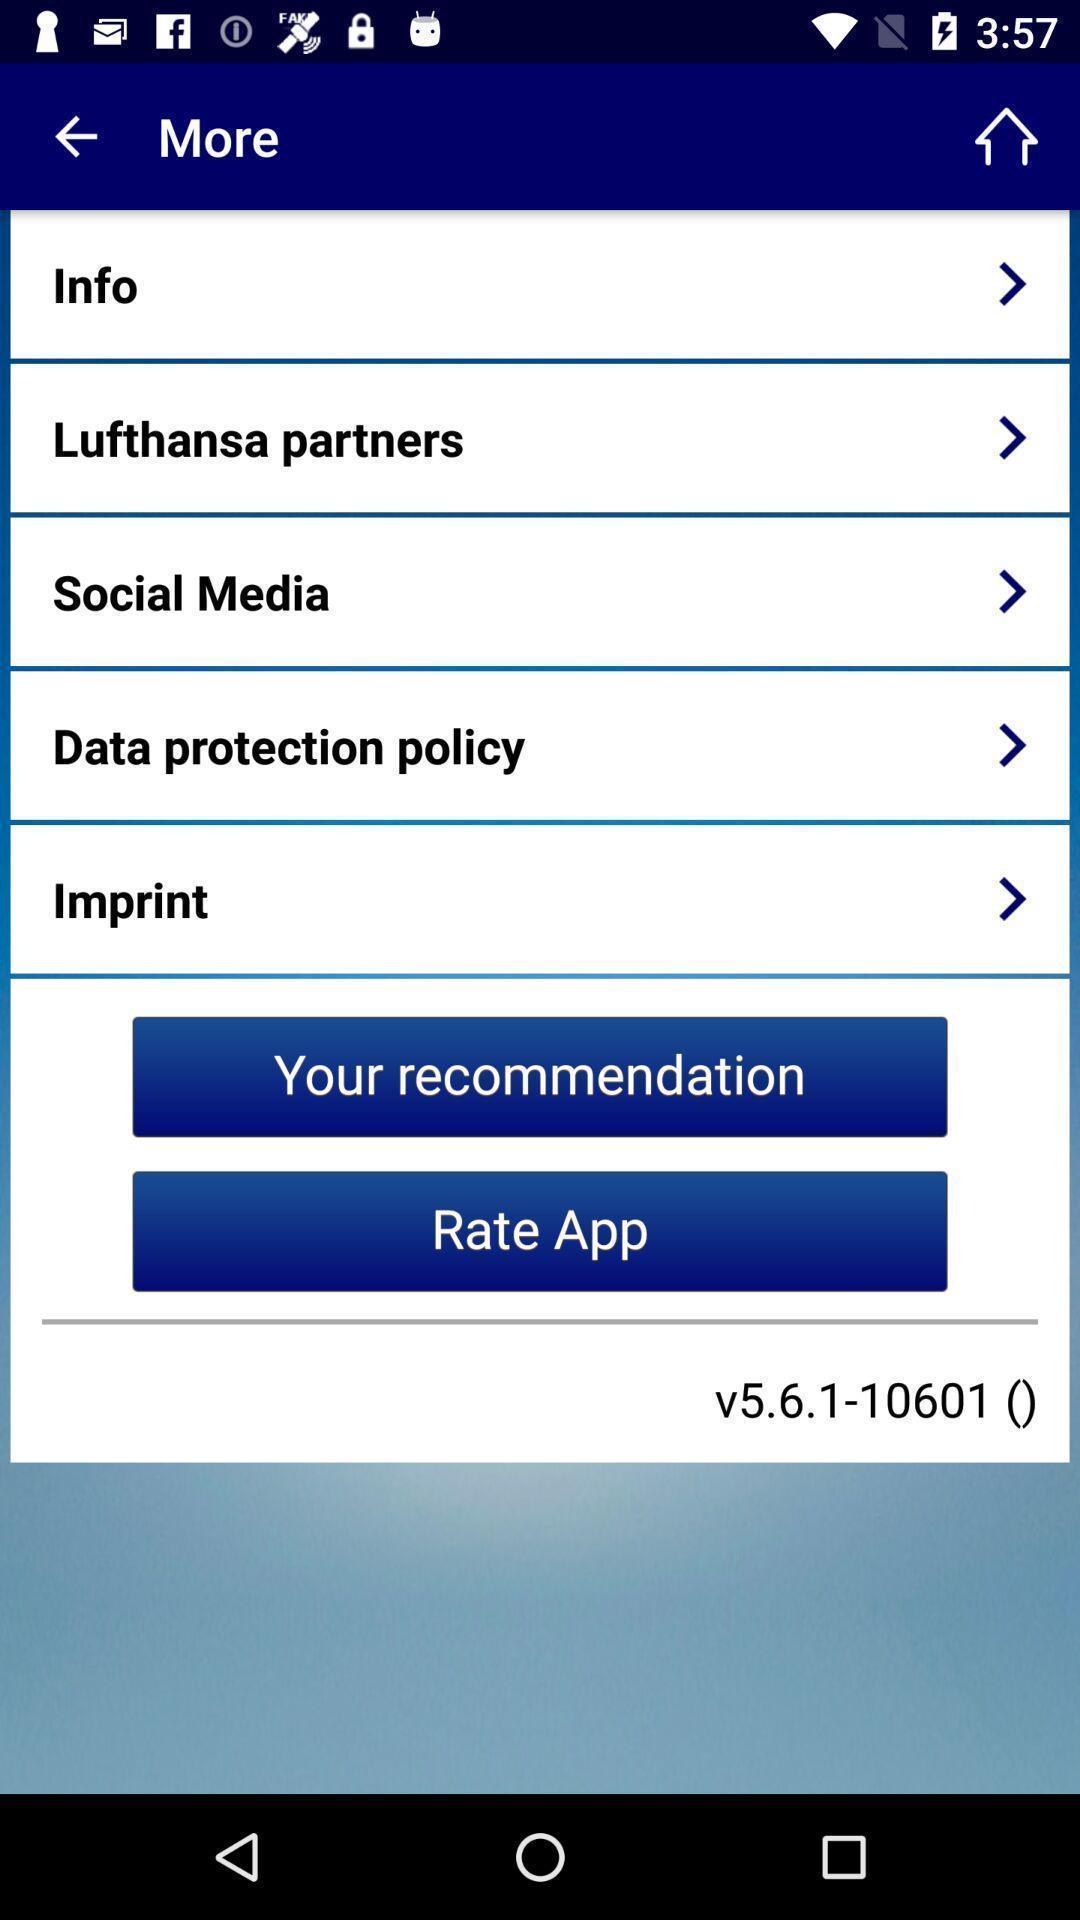Describe this image in words. Screen showing options in more. 